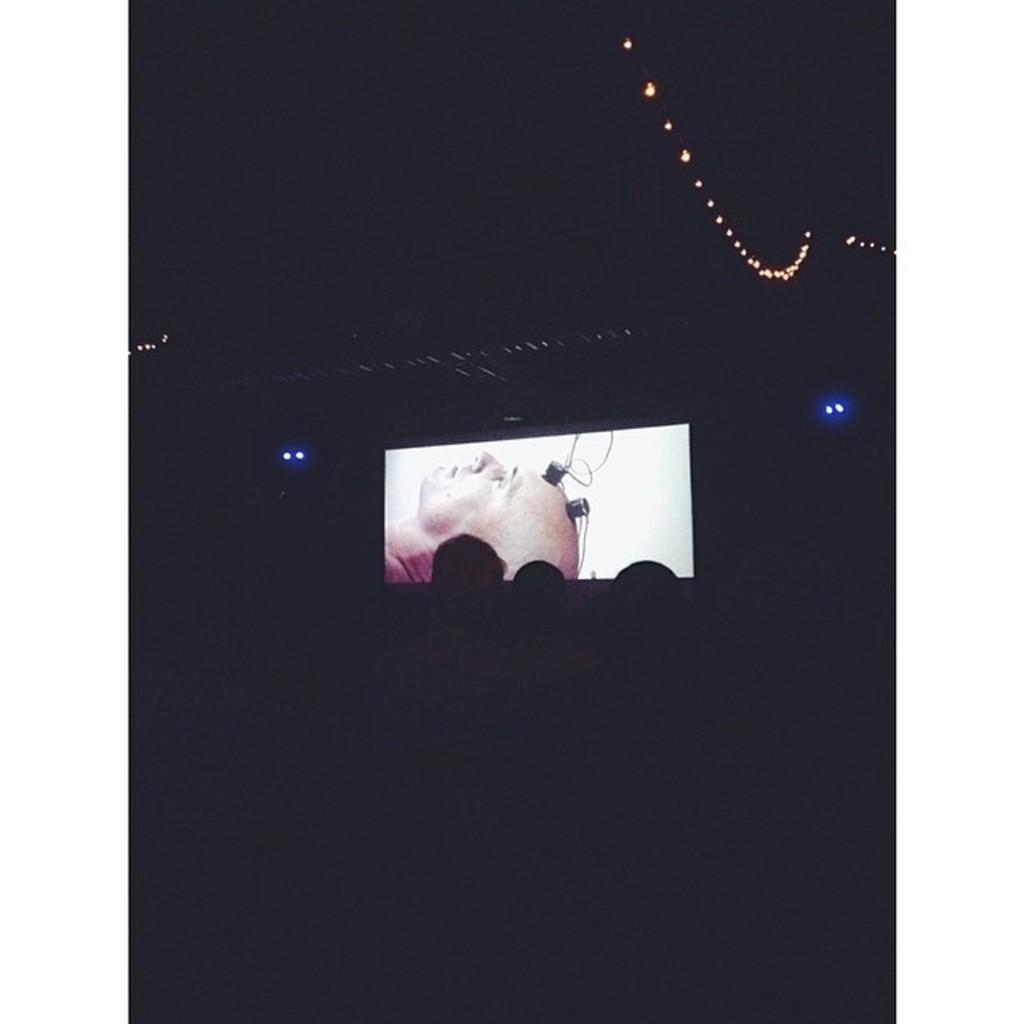What is the main object in the image? There is a screen in the image. What can be seen on the screen? There is a person on the screen. Are there any other people visible in the image? Yes, there are people in the image. What else can be seen in the image besides the screen and people? There are lights in the image. How would you describe the overall lighting in the image? The background of the image is dark. Can you tell me how many squirrels are running along the route in the image? There are no squirrels or routes present in the image; it features a screen with a person and people in a dark environment with lights. 